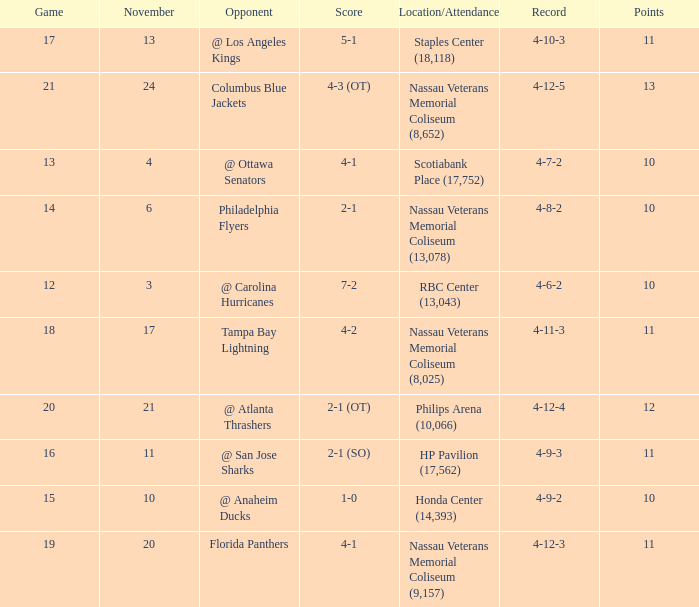What is the least entry for game if the score is 1-0? 15.0. 